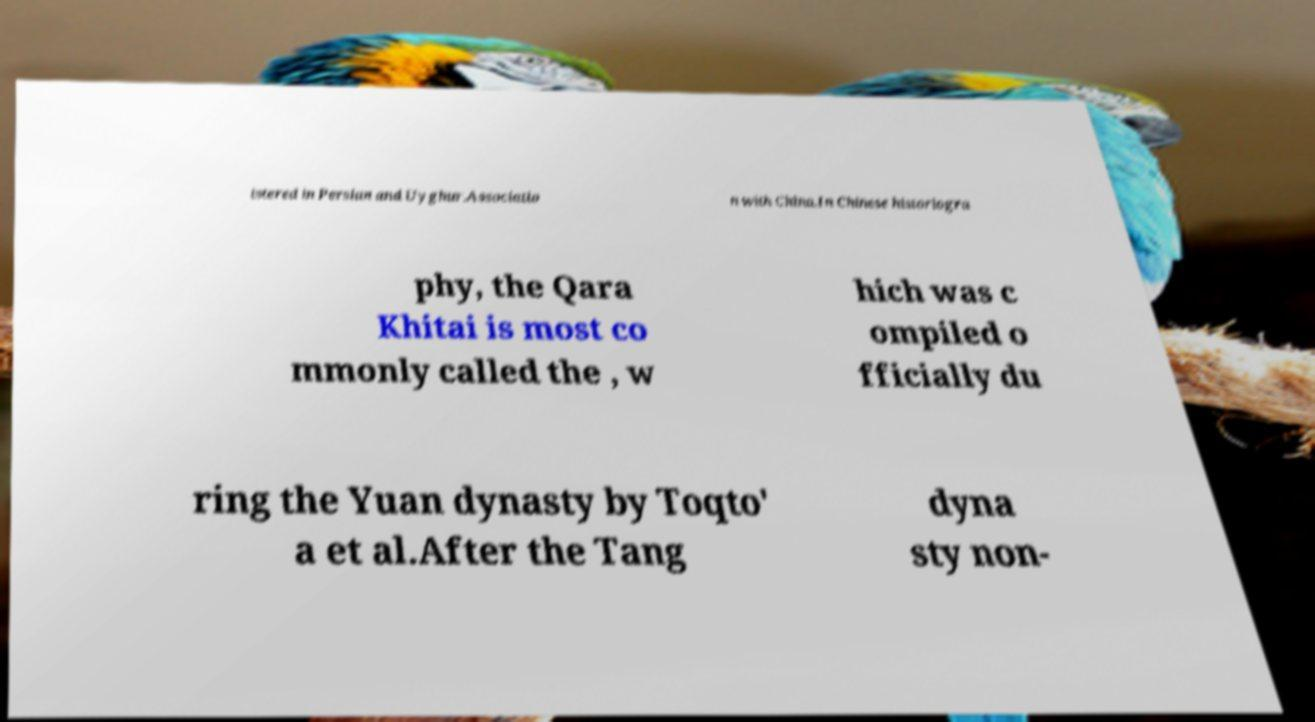Could you assist in decoding the text presented in this image and type it out clearly? istered in Persian and Uyghur.Associatio n with China.In Chinese historiogra phy, the Qara Khitai is most co mmonly called the , w hich was c ompiled o fficially du ring the Yuan dynasty by Toqto' a et al.After the Tang dyna sty non- 